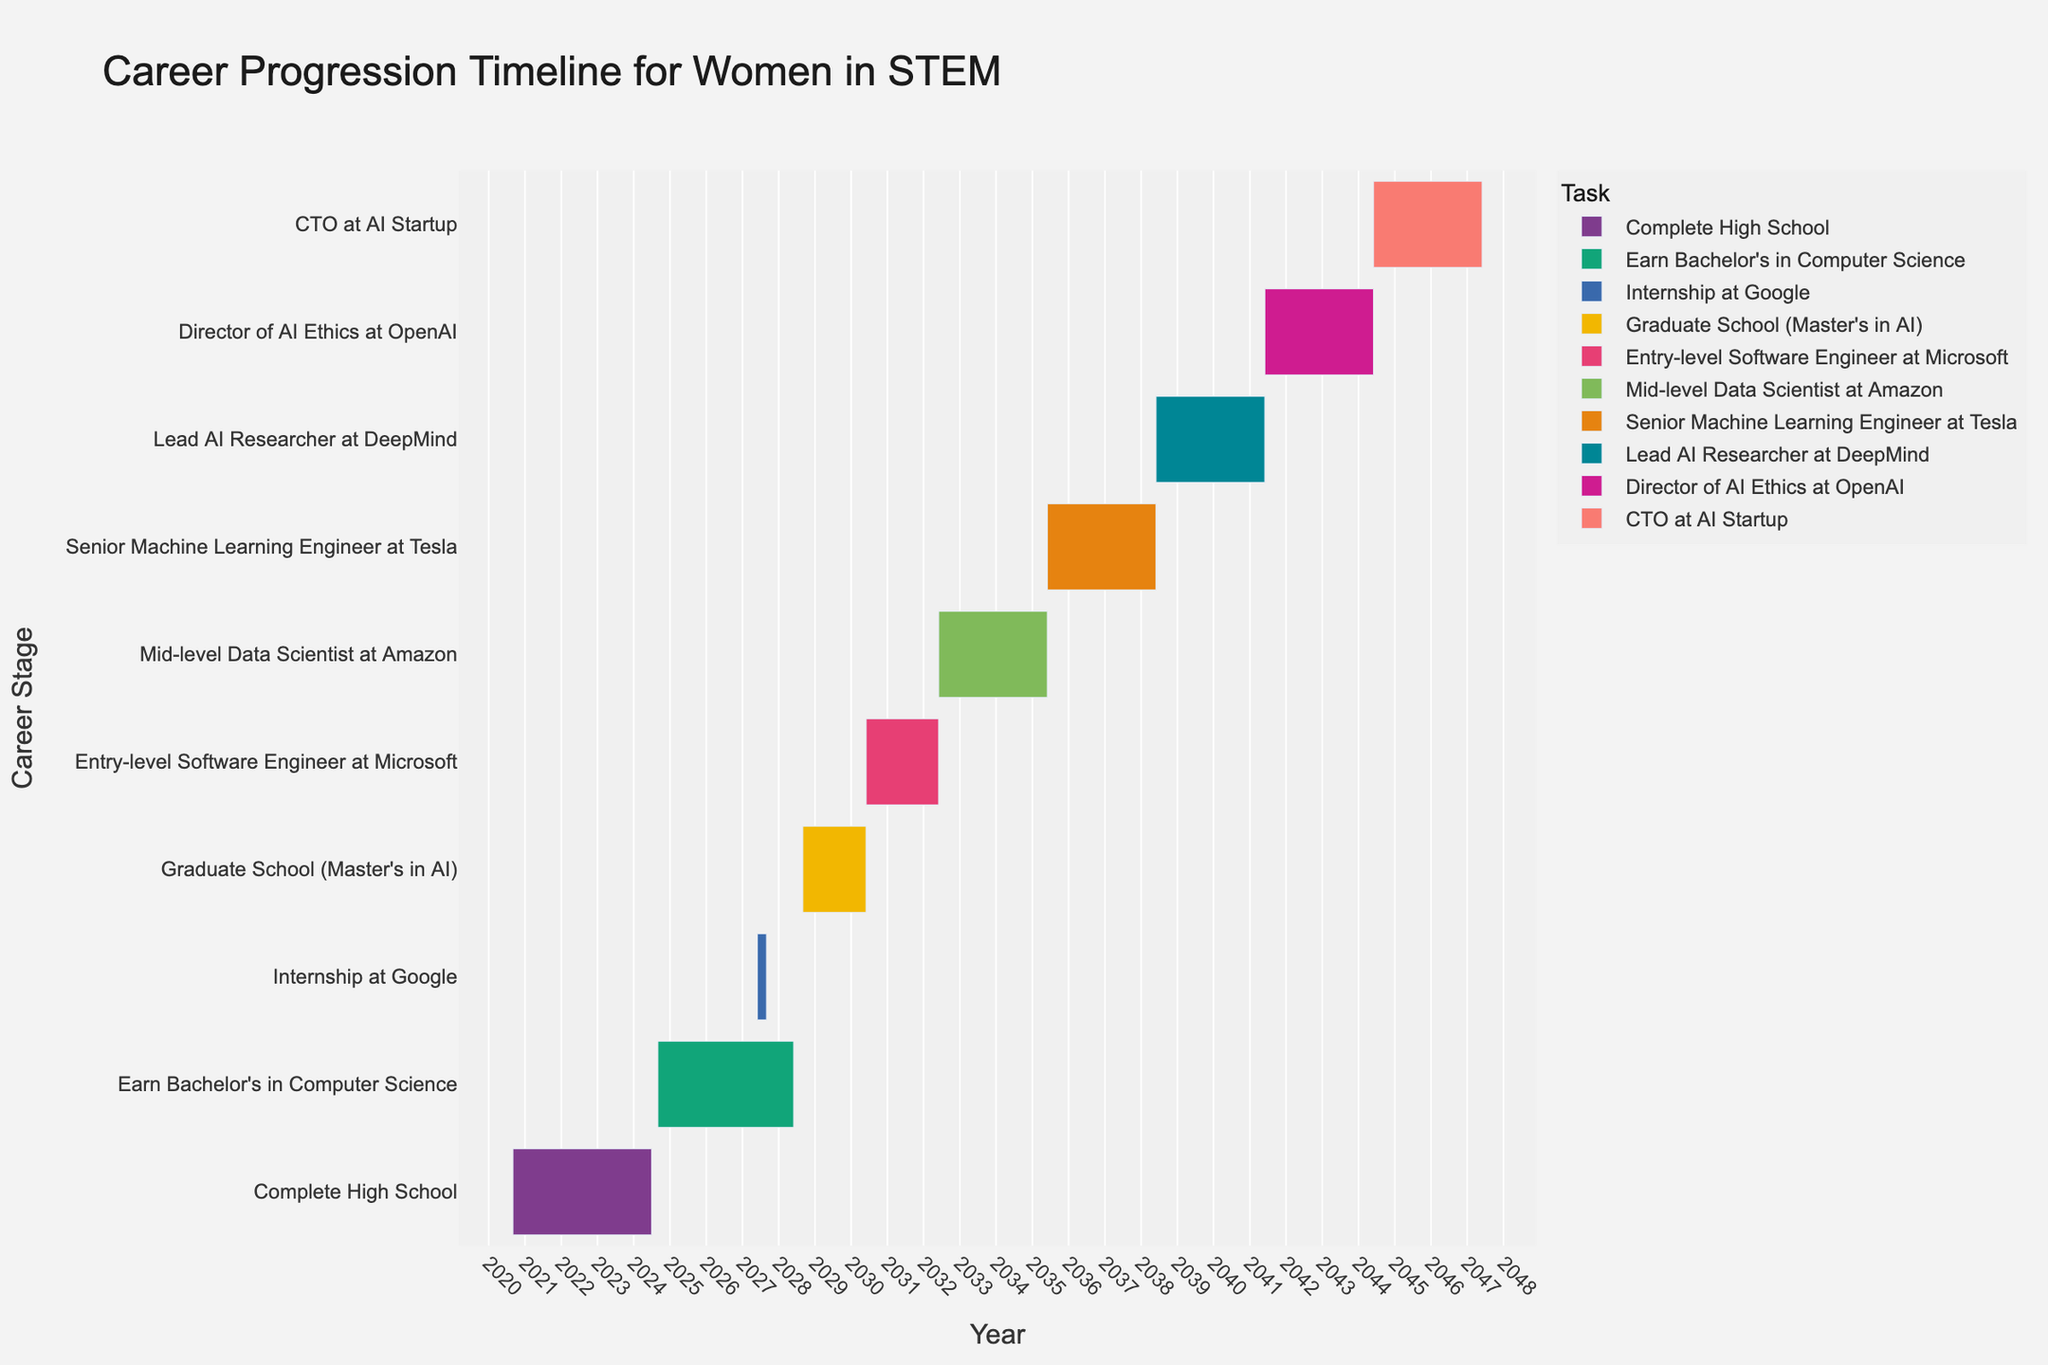When does the timeline for "Graduate School (Master's in AI)" start and end? Locate the task "Graduate School (Master's in AI)" on the y-axis and observe the corresponding positions on the x-axis for the start and end dates.
Answer: Starts: September 2028, Ends: May 2030 What task follows immediately after "Earn Bachelor's in Computer Science"? Find the task "Earn Bachelor's in Computer Science" on the timeline and look for the next task chronologically.
Answer: Internship at Google Which task has the longest duration? Compare the length of the bars on the timeline to determine which one is longest.
Answer: CTO at AI Startup How many months are spent in the "Entry-level Software Engineer at Microsoft" phase? Calculate the difference between the start and end dates for the "Entry-level Software Engineer at Microsoft" task: from June 2030 to May 2032.
Answer: 24 months (2 years) What is the color used for the "Mid-level Data Scientist at Amazon" task? Find the "Mid-level Data Scientist at Amazon" bar on the timeline and identify its color.
Answer: This task is plotted in a specific color range which appears in the figure What are the educational milestones included in the timeline? Identify all the tasks related to education by reading their descriptions.
Answer: Complete High School, Earn Bachelor's in Computer Science, Graduate School (Master's in AI) Between which years does the "Senior Machine Learning Engineer at Tesla" phase occur? Find the "Senior Machine Learning Engineer at Tesla" task and note its start and end years from the x-axis.
Answer: 2035-2038 How does the duration of "Lead AI Researcher at DeepMind" compare to "Director of AI Ethics at OpenAI"? Measure the duration of both tasks by comparing the length of their bars on the timeline. "Lead AI Researcher at DeepMind" runs from June 2038 to May 2041, while "Director of AI Ethics at OpenAI" runs from June 2041 to May 2044. Both tasks have the same duration.
Answer: Equal duration: 3 years each What is the final job level in the timeline and when does it end? Identify the last task on the y-axis and note its title and end date.
Answer: CTO at AI Startup, Ends: May 2047 Which phase lasts exactly 3 years and starts after 2035? Search for tasks after the year 2035 and check their durations; identify the one lasting exactly 3 years.
Answer: Lead AI Researcher at DeepMind 